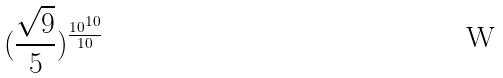<formula> <loc_0><loc_0><loc_500><loc_500>( \frac { \sqrt { 9 } } { 5 } ) ^ { \frac { 1 0 ^ { 1 0 } } { 1 0 } }</formula> 